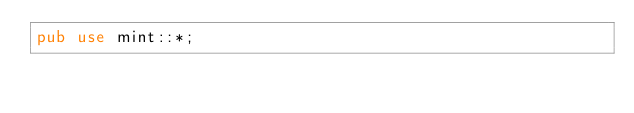<code> <loc_0><loc_0><loc_500><loc_500><_Rust_>pub use mint::*;
</code> 